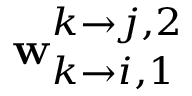<formula> <loc_0><loc_0><loc_500><loc_500>w _ { k \rightarrow i , 1 } ^ { k \rightarrow j , 2 }</formula> 